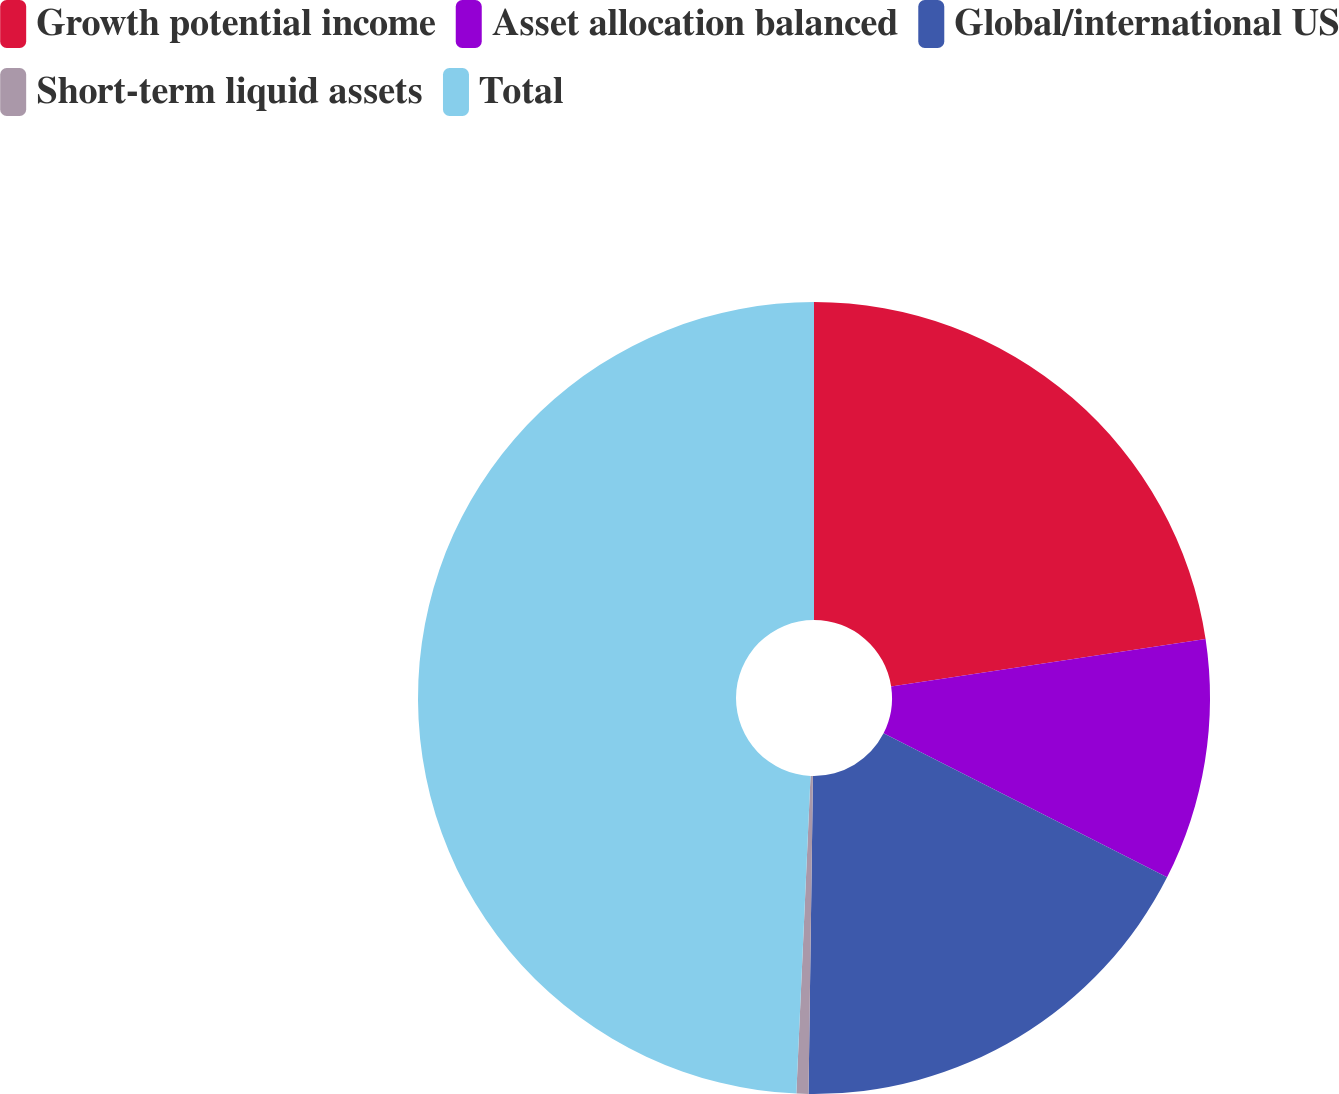Convert chart. <chart><loc_0><loc_0><loc_500><loc_500><pie_chart><fcel>Growth potential income<fcel>Asset allocation balanced<fcel>Global/international US<fcel>Short-term liquid assets<fcel>Total<nl><fcel>22.62%<fcel>9.86%<fcel>17.74%<fcel>0.49%<fcel>49.29%<nl></chart> 